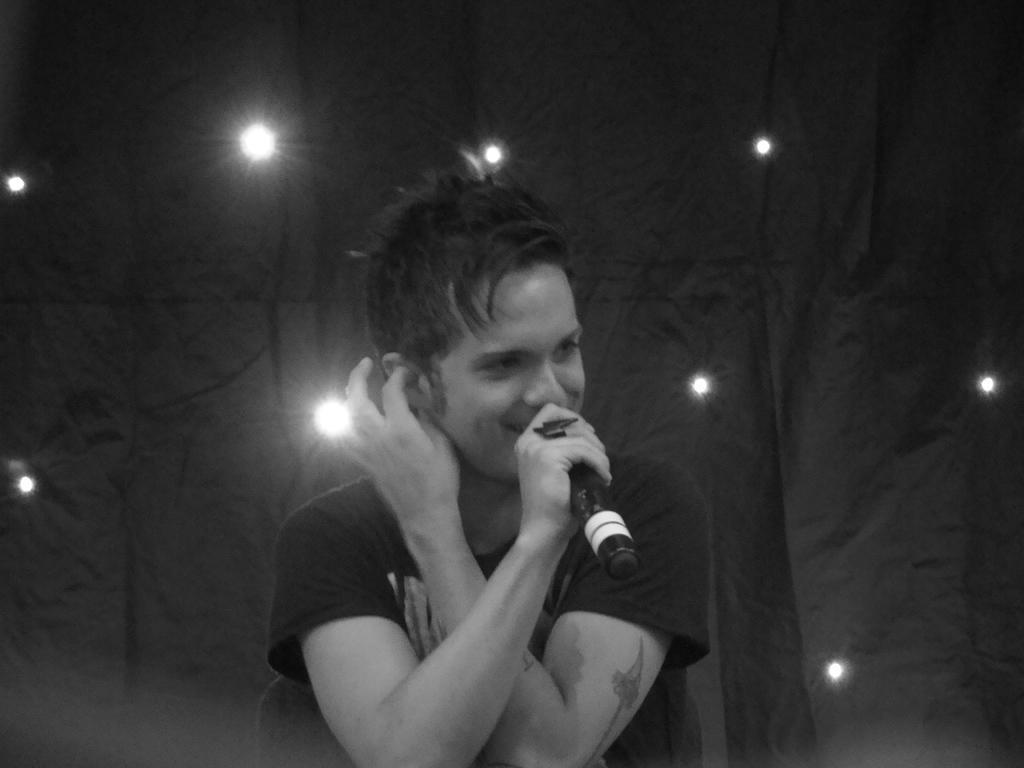Could you give a brief overview of what you see in this image? There is a boy in this picture holding a mic in his hands. In the background there is a cloth and some lights. 